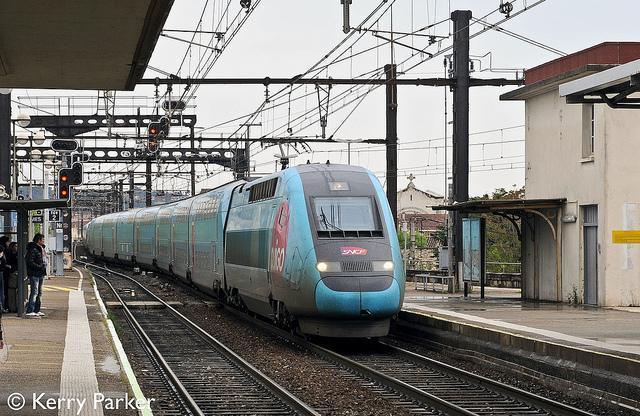How many chairs are visible?
Give a very brief answer. 0. 